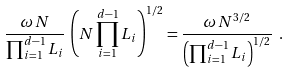Convert formula to latex. <formula><loc_0><loc_0><loc_500><loc_500>\frac { \omega \, N } { \prod _ { i = 1 } ^ { d - 1 } L _ { i } } \, \left ( N \prod _ { i = 1 } ^ { d - 1 } L _ { i } \right ) ^ { 1 / 2 } = \frac { \omega \, N ^ { 3 / 2 } } { \left ( \prod _ { i = 1 } ^ { d - 1 } L _ { i } \right ) ^ { 1 / 2 } } \ .</formula> 